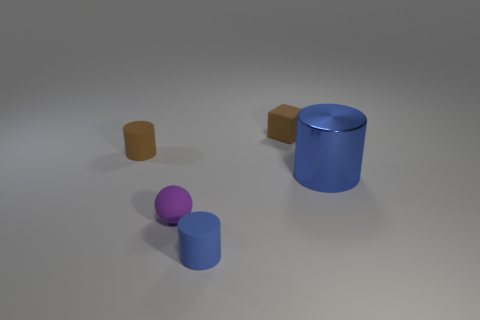There is a rubber thing that is both behind the purple ball and to the right of the brown cylinder; what is its shape?
Provide a short and direct response. Cube. Is there a blue ball that has the same material as the small purple thing?
Ensure brevity in your answer.  No. What material is the cylinder that is the same color as the rubber block?
Your answer should be compact. Rubber. Is the blue cylinder that is behind the rubber ball made of the same material as the brown thing that is on the right side of the purple object?
Your answer should be very brief. No. Is the number of big blue objects greater than the number of tiny yellow rubber things?
Offer a very short reply. Yes. What color is the cylinder that is on the right side of the tiny brown matte object that is behind the tiny matte cylinder behind the big metal object?
Give a very brief answer. Blue. There is a small matte cylinder behind the tiny blue thing; is its color the same as the rubber thing right of the small blue cylinder?
Your answer should be compact. Yes. There is a small object on the right side of the tiny blue matte cylinder; how many tiny blocks are to the left of it?
Provide a succinct answer. 0. Are there any yellow cylinders?
Provide a succinct answer. No. What number of other things are there of the same color as the sphere?
Your answer should be compact. 0. 